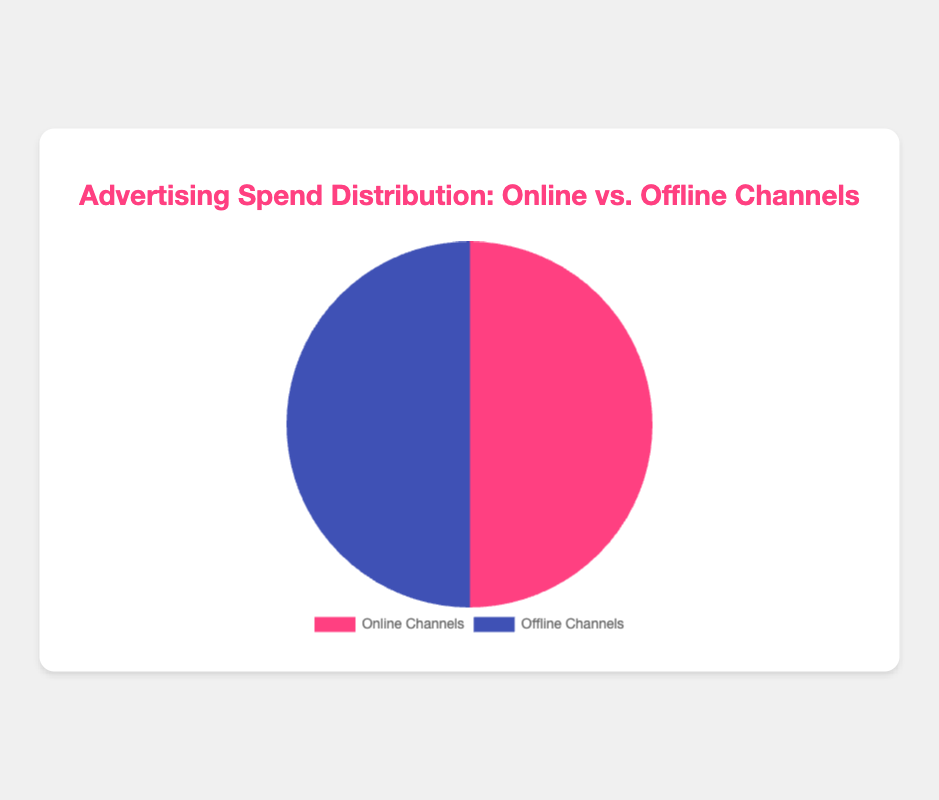What is the total percentage spent on online advertising channels? Sum the percentages for Instagram Ads (25), Facebook Ads (20), Google Ads (30), YouTube Ads (15), and TikTok Ads (10). 25 + 20 + 30 + 15 + 10 = 100
Answer: 100% What is the difference in percentage between the largest and smallest online advertising channels? Google Ads is the largest (30%) and TikTok Ads is the smallest (10%). The difference is 30 - 10 = 20%
Answer: 20% Which offline advertising channel has the highest percentage of the spend? Identify the highest percentage among Billboards (40%), TV Commercials (30%), Radio Spots (20%), and Print Media (10%). Billboards have the highest percentage.
Answer: Billboards What is the combined percentage of spend on TV Commercials and Radio Spots? TV Commercials account for 30% and Radio Spots for 20%. Sum them up: 30 + 20 = 50
Answer: 50% Is the percentage spent on YouTube Ads greater than or less than that on Print Media? YouTube Ads account for 15% and Print Media for 10%. 15% is greater than 10%
Answer: Greater What is the average percentage spend on online channels? Sum the percentages for online channels (25+20+30+15+10 = 100) and divide by the number of channels (5). 100 / 5 = 20
Answer: 20% How much more is spent on Billboards compared to Google Ads? Billboards account for 40% and Google Ads for 30%. The difference is 40 - 30 = 10%
Answer: 10% If we combined the spend on Instagram Ads and Facebook Ads, which offline channel would it be closest to? Instagram Ads (25%) + Facebook Ads (20%) = 45%. Compare 45% to Billboards (40%), TV Commercials (30%), Radio Spots (20%), and Print Media (10%). Closest to Billboards (40%)
Answer: Billboards Which type of channel (online or offline) has more categories involved in the advertising spend distribution? Online channels have 5 categories (Instagram, Facebook, Google, YouTube, TikTok). Offline channels have 4 categories (Billboards, TV Commercials, Radio Spots, Print Media).
Answer: Online channels 